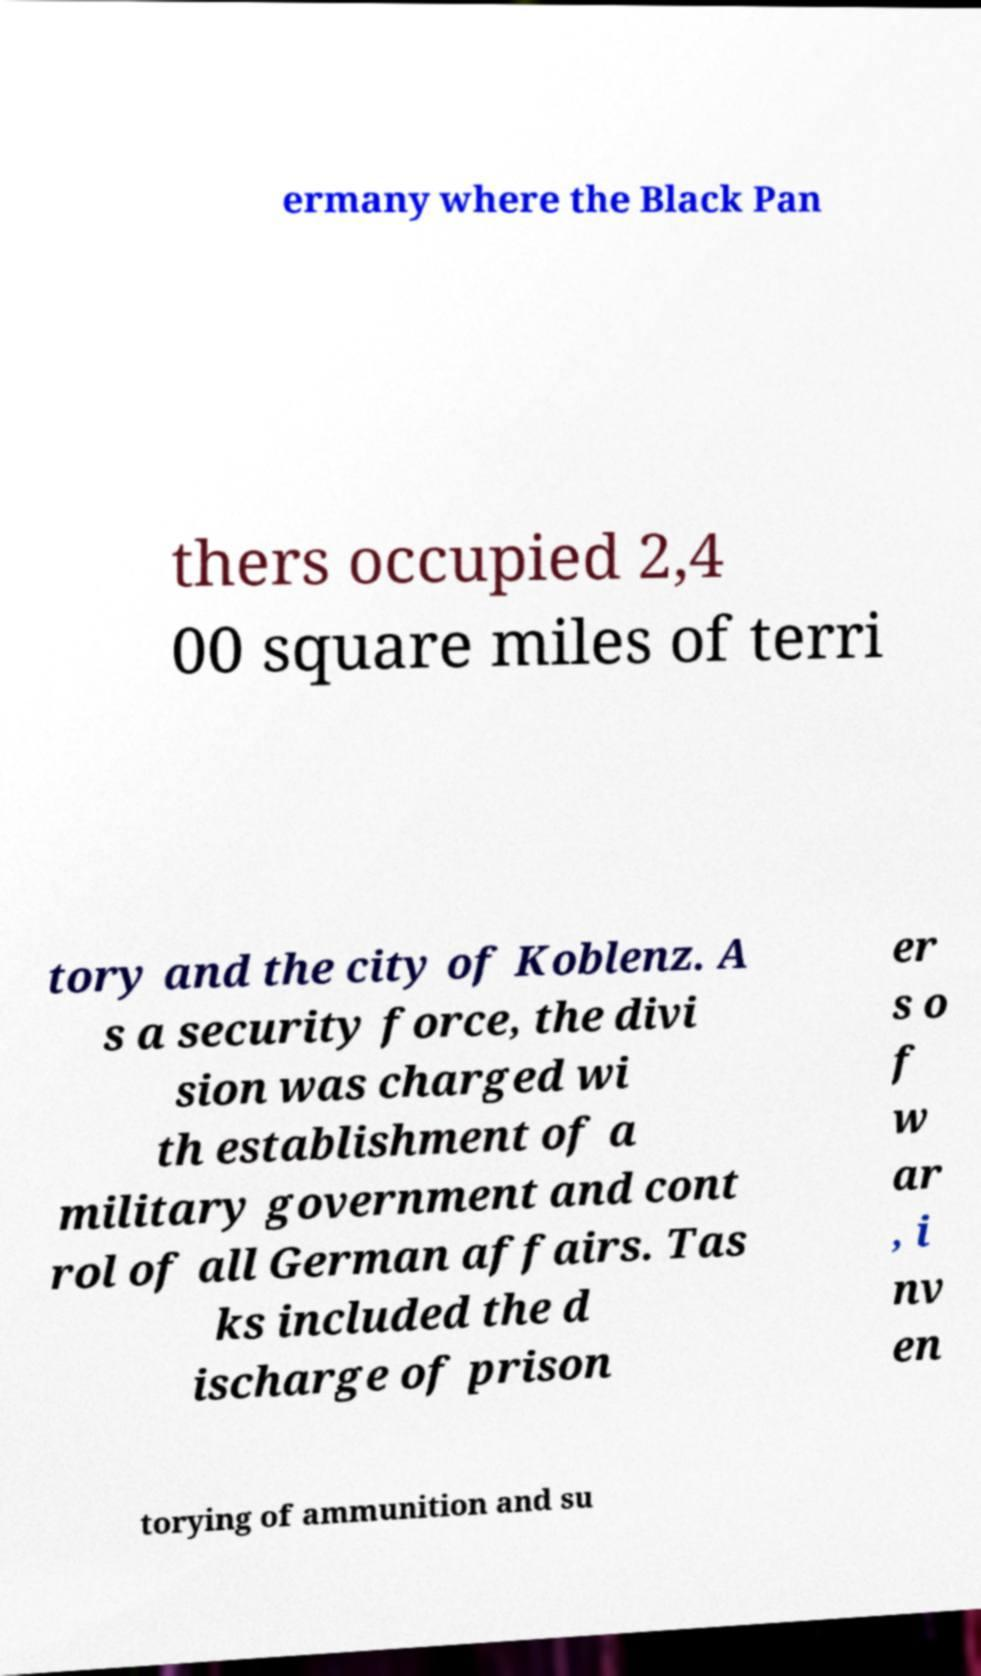What messages or text are displayed in this image? I need them in a readable, typed format. ermany where the Black Pan thers occupied 2,4 00 square miles of terri tory and the city of Koblenz. A s a security force, the divi sion was charged wi th establishment of a military government and cont rol of all German affairs. Tas ks included the d ischarge of prison er s o f w ar , i nv en torying of ammunition and su 